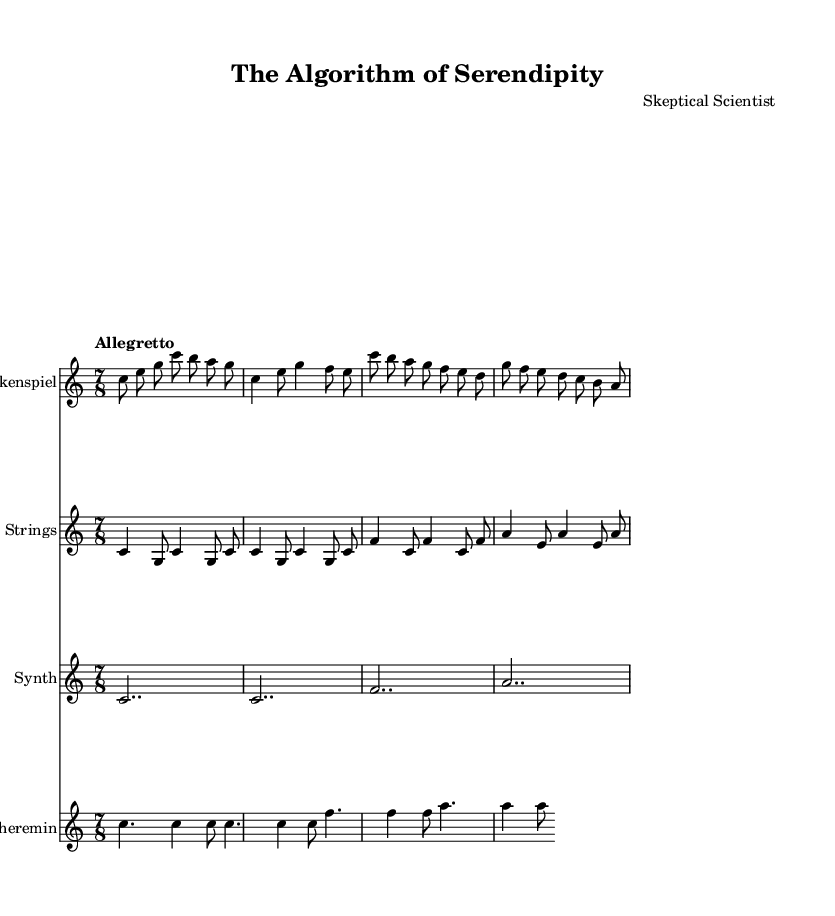What is the key signature of this music? The key signature is found at the beginning of the staff. It indicates C major, which is noted by the absence of any sharps or flats.
Answer: C major What is the time signature of this music? The time signature is located at the beginning of the score, showing that there are seven beats in a bar, as indicated by the 7/8 notation.
Answer: 7/8 What is the tempo marking for this piece? The tempo is indicated at the start of the music with the term "Allegretto," which suggests a moderately fast pace, typically around 98-109 beats per minute.
Answer: Allegretto How many different instruments are used in this score? By examining the different staves, we can see that there are four distinct instruments: Glockenspiel, Pizz. Strings, Synth, and Theremin.
Answer: Four Which instrument plays the highest pitches? The Glockenspiel is noted for its bright, high-pitched tones that generally sound above the other instruments in this composition, especially when comparing the ranges.
Answer: Glockenspiel What is the rhythmic style used in this piece? The unique 7/8 time signature creates an irregular, off-kilter rhythmic style, which is characteristic of quirky and eccentric soundtracks often found in indie films.
Answer: Quirky 